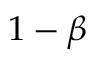<formula> <loc_0><loc_0><loc_500><loc_500>1 - \beta</formula> 